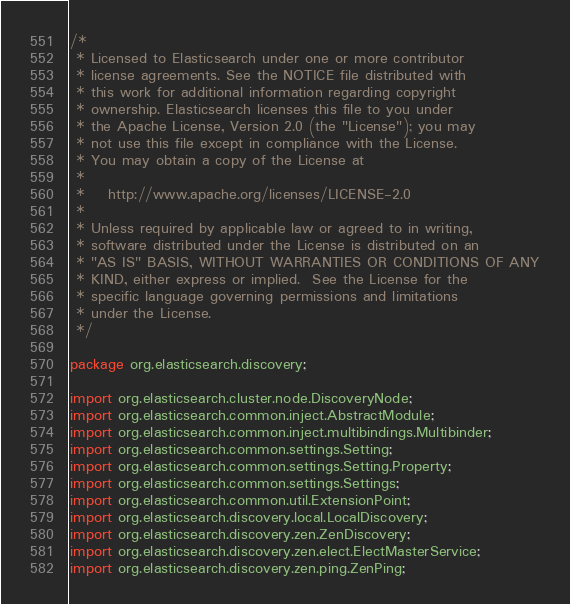Convert code to text. <code><loc_0><loc_0><loc_500><loc_500><_Java_>/*
 * Licensed to Elasticsearch under one or more contributor
 * license agreements. See the NOTICE file distributed with
 * this work for additional information regarding copyright
 * ownership. Elasticsearch licenses this file to you under
 * the Apache License, Version 2.0 (the "License"); you may
 * not use this file except in compliance with the License.
 * You may obtain a copy of the License at
 *
 *    http://www.apache.org/licenses/LICENSE-2.0
 *
 * Unless required by applicable law or agreed to in writing,
 * software distributed under the License is distributed on an
 * "AS IS" BASIS, WITHOUT WARRANTIES OR CONDITIONS OF ANY
 * KIND, either express or implied.  See the License for the
 * specific language governing permissions and limitations
 * under the License.
 */

package org.elasticsearch.discovery;

import org.elasticsearch.cluster.node.DiscoveryNode;
import org.elasticsearch.common.inject.AbstractModule;
import org.elasticsearch.common.inject.multibindings.Multibinder;
import org.elasticsearch.common.settings.Setting;
import org.elasticsearch.common.settings.Setting.Property;
import org.elasticsearch.common.settings.Settings;
import org.elasticsearch.common.util.ExtensionPoint;
import org.elasticsearch.discovery.local.LocalDiscovery;
import org.elasticsearch.discovery.zen.ZenDiscovery;
import org.elasticsearch.discovery.zen.elect.ElectMasterService;
import org.elasticsearch.discovery.zen.ping.ZenPing;</code> 